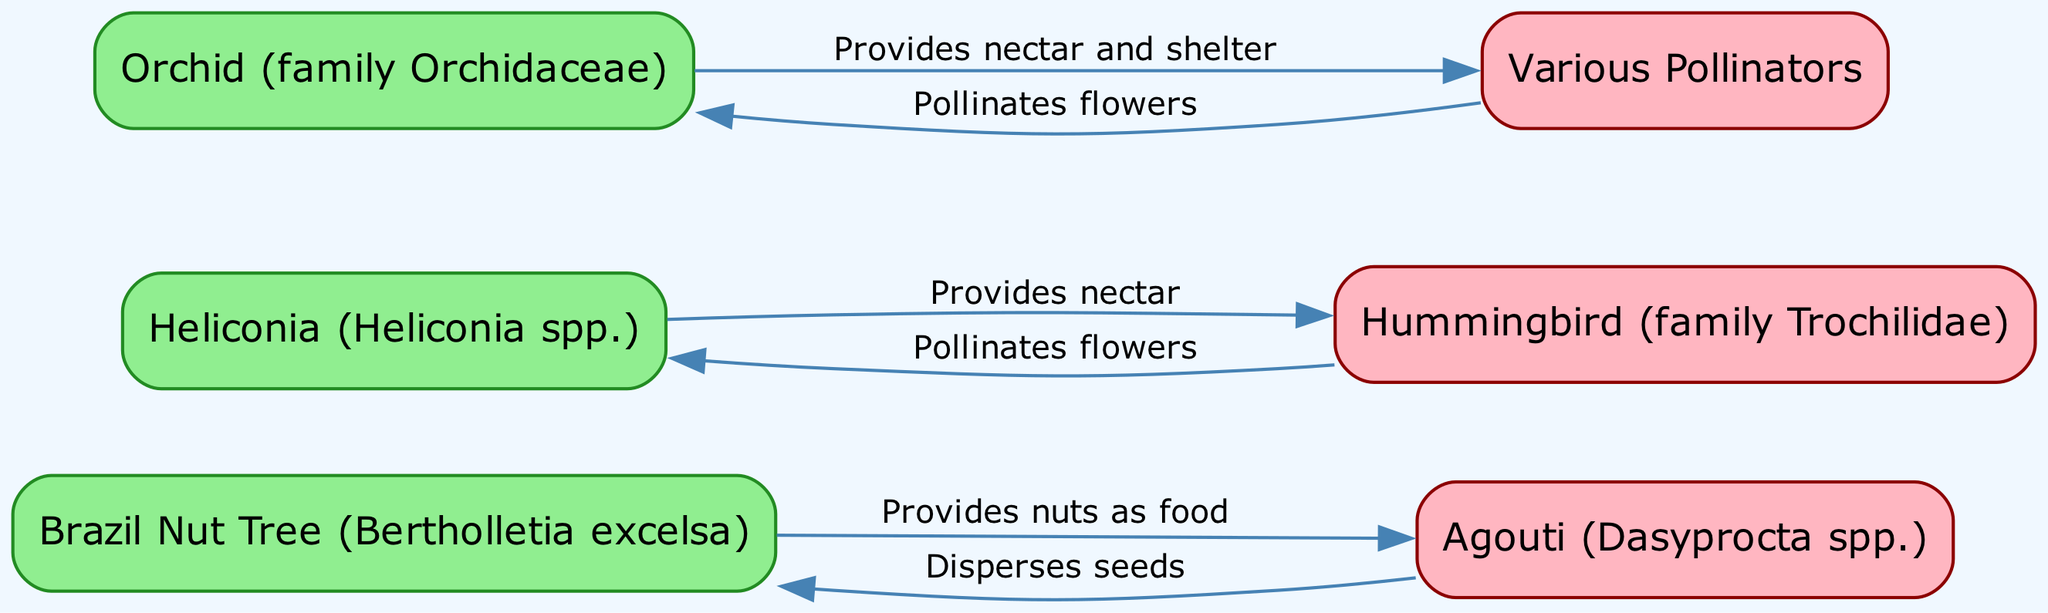What is the relationship between the Brazil Nut Tree and the Agouti? The diagram indicates that the Brazil Nut Tree provides nuts as food for the Agouti, and in turn, the Agouti disperses the seeds of the Brazil Nut Tree. This direct relationship is captured in the edges connecting these two nodes.
Answer: Provides nuts as food How many total nodes are present in the diagram? By counting the unique elements that appear in the nodes section of the data, we find there are six nodes: Brazil Nut Tree, Agouti, Heliconia, Hummingbird, Orchid, and Pollinators.
Answer: 6 Which species is helped by pollinators according to the diagram? The diagram shows that the Orchid provides nectar and shelter to various pollinators, and it also mentions that pollinators assist by pollinating the Orchid's flowers.
Answer: Orchid What does the Hummingbird provide to the Heliconia? The Hummingbird is shown to receive nectar from the Heliconia, which is essential for its feeding. This connection emphasizes the role of Heliconia in sustaining Hummingbird species.
Answer: Provides nectar How many edges connect the Brazil Nut Tree and the Agouti? There are two edges connecting these nodes: one states that the Brazil Nut Tree provides food (nuts) to the Agouti, and the other mentions that the Agouti disperses the seeds of the Brazil Nut Tree.
Answer: 2 What action do pollinators take towards orchids? The pollinators are depicted as pollinating the flowers of the Orchid in the diagram, signifying their role in the reproduction process of this plant species.
Answer: Pollinates flowers Which plant type is connected to the greatest number of animals based on the diagram? The Brazil Nut Tree is directly connected to one animal: the Agouti, whereas Heliconia is connected to Hummingbirds and Orchid to various pollinators. However, Orchid shares connections with two different categories of pollinators. This indicates that Orchid has ties to a broader set of interactions.
Answer: Orchid Which species is responsible for pollinating Heliconia? The diagram clearly states that the Hummingbird plays a critical role in pollinating Heliconia flowers, indicating a mutual relationship between these two species.
Answer: Hummingbird 